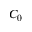Convert formula to latex. <formula><loc_0><loc_0><loc_500><loc_500>C _ { 0 }</formula> 